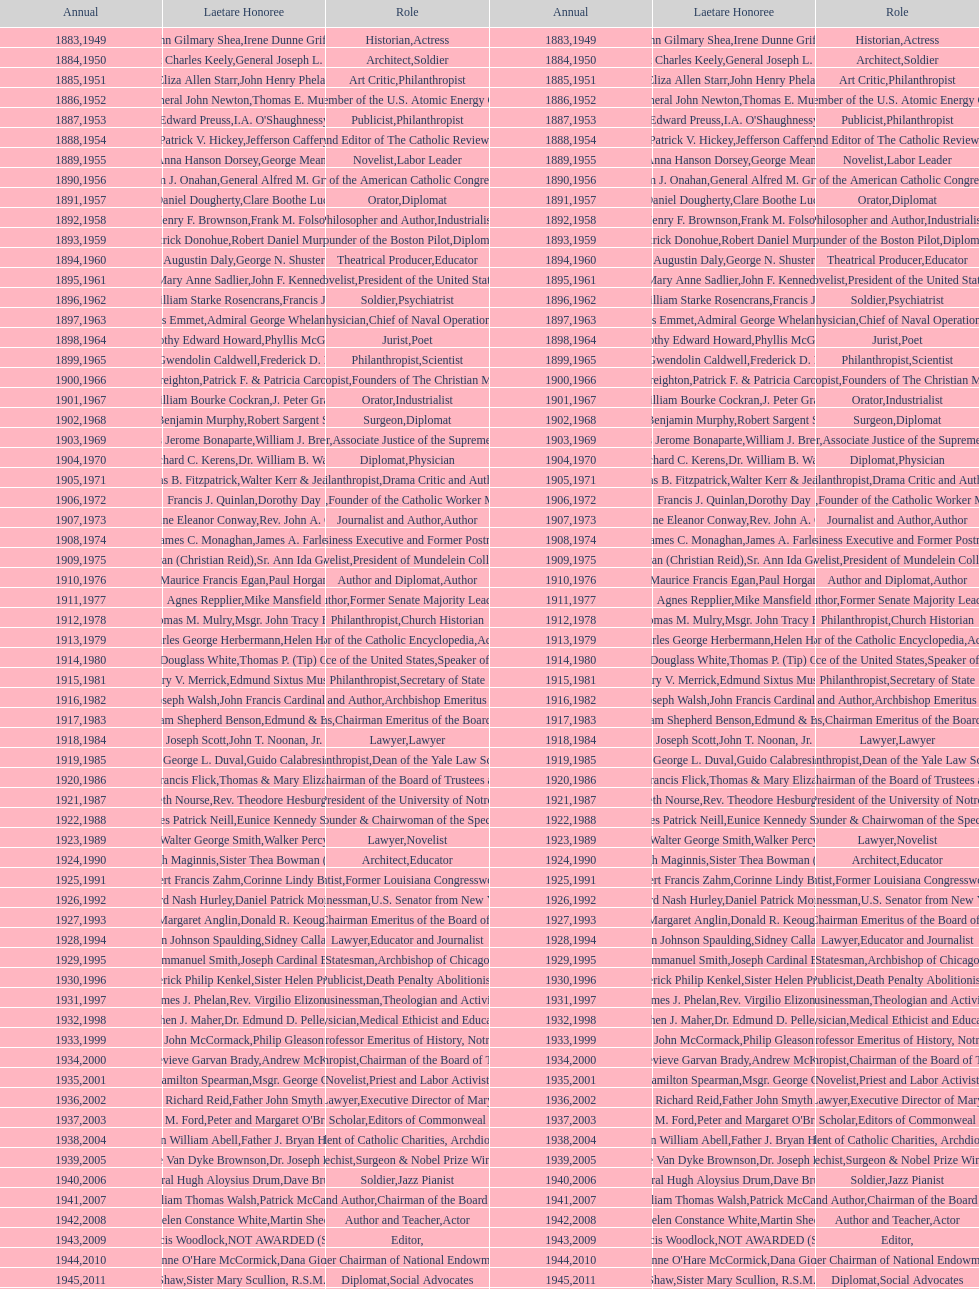How many times does philanthropist appear in the position column on this chart? 9. 